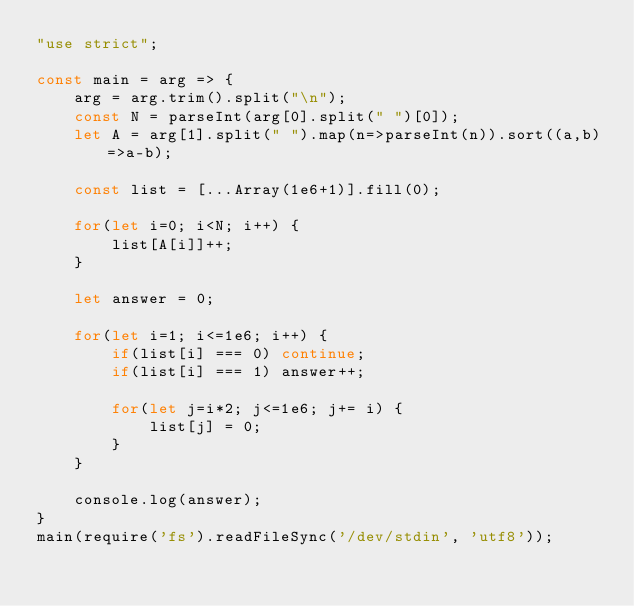Convert code to text. <code><loc_0><loc_0><loc_500><loc_500><_JavaScript_>"use strict";
    
const main = arg => {
    arg = arg.trim().split("\n");
    const N = parseInt(arg[0].split(" ")[0]);
    let A = arg[1].split(" ").map(n=>parseInt(n)).sort((a,b)=>a-b);
    
    const list = [...Array(1e6+1)].fill(0);
    
    for(let i=0; i<N; i++) {
        list[A[i]]++;
    }
    
    let answer = 0;
    
    for(let i=1; i<=1e6; i++) {
        if(list[i] === 0) continue;
        if(list[i] === 1) answer++;
        
        for(let j=i*2; j<=1e6; j+= i) {
            list[j] = 0;
        }
    }
    
    console.log(answer);
}
main(require('fs').readFileSync('/dev/stdin', 'utf8'));
</code> 